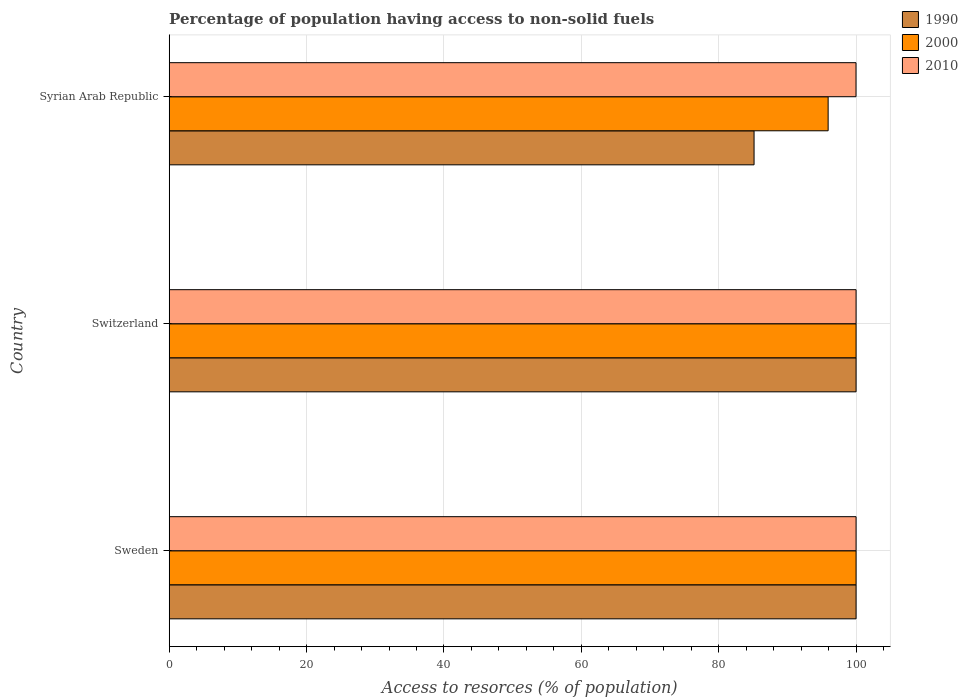How many different coloured bars are there?
Provide a succinct answer. 3. How many bars are there on the 2nd tick from the bottom?
Make the answer very short. 3. What is the label of the 2nd group of bars from the top?
Provide a short and direct response. Switzerland. In how many cases, is the number of bars for a given country not equal to the number of legend labels?
Your answer should be very brief. 0. What is the percentage of population having access to non-solid fuels in 1990 in Syrian Arab Republic?
Offer a terse response. 85.15. Across all countries, what is the minimum percentage of population having access to non-solid fuels in 1990?
Your answer should be very brief. 85.15. In which country was the percentage of population having access to non-solid fuels in 1990 minimum?
Offer a very short reply. Syrian Arab Republic. What is the total percentage of population having access to non-solid fuels in 1990 in the graph?
Your answer should be very brief. 285.15. What is the difference between the percentage of population having access to non-solid fuels in 2000 in Sweden and that in Switzerland?
Provide a short and direct response. 0. What is the average percentage of population having access to non-solid fuels in 1990 per country?
Offer a very short reply. 95.05. What is the difference between the percentage of population having access to non-solid fuels in 2010 and percentage of population having access to non-solid fuels in 2000 in Syrian Arab Republic?
Offer a very short reply. 4.06. In how many countries, is the percentage of population having access to non-solid fuels in 1990 greater than 60 %?
Offer a very short reply. 3. What is the ratio of the percentage of population having access to non-solid fuels in 2000 in Switzerland to that in Syrian Arab Republic?
Offer a very short reply. 1.04. What is the difference between the highest and the lowest percentage of population having access to non-solid fuels in 2010?
Make the answer very short. 0.01. Is the sum of the percentage of population having access to non-solid fuels in 1990 in Sweden and Switzerland greater than the maximum percentage of population having access to non-solid fuels in 2000 across all countries?
Ensure brevity in your answer.  Yes. Are all the bars in the graph horizontal?
Provide a short and direct response. Yes. How many countries are there in the graph?
Keep it short and to the point. 3. What is the difference between two consecutive major ticks on the X-axis?
Provide a succinct answer. 20. Are the values on the major ticks of X-axis written in scientific E-notation?
Give a very brief answer. No. Does the graph contain any zero values?
Your response must be concise. No. Does the graph contain grids?
Make the answer very short. Yes. Where does the legend appear in the graph?
Ensure brevity in your answer.  Top right. How many legend labels are there?
Ensure brevity in your answer.  3. What is the title of the graph?
Your answer should be very brief. Percentage of population having access to non-solid fuels. What is the label or title of the X-axis?
Give a very brief answer. Access to resorces (% of population). What is the label or title of the Y-axis?
Ensure brevity in your answer.  Country. What is the Access to resorces (% of population) of 1990 in Sweden?
Give a very brief answer. 100. What is the Access to resorces (% of population) of 2000 in Sweden?
Your response must be concise. 100. What is the Access to resorces (% of population) of 2010 in Sweden?
Make the answer very short. 100. What is the Access to resorces (% of population) of 1990 in Switzerland?
Offer a very short reply. 100. What is the Access to resorces (% of population) in 2000 in Switzerland?
Your response must be concise. 100. What is the Access to resorces (% of population) in 1990 in Syrian Arab Republic?
Offer a very short reply. 85.15. What is the Access to resorces (% of population) in 2000 in Syrian Arab Republic?
Keep it short and to the point. 95.93. What is the Access to resorces (% of population) of 2010 in Syrian Arab Republic?
Give a very brief answer. 99.99. Across all countries, what is the maximum Access to resorces (% of population) in 2000?
Offer a very short reply. 100. Across all countries, what is the maximum Access to resorces (% of population) in 2010?
Your response must be concise. 100. Across all countries, what is the minimum Access to resorces (% of population) of 1990?
Give a very brief answer. 85.15. Across all countries, what is the minimum Access to resorces (% of population) in 2000?
Your answer should be compact. 95.93. Across all countries, what is the minimum Access to resorces (% of population) in 2010?
Ensure brevity in your answer.  99.99. What is the total Access to resorces (% of population) of 1990 in the graph?
Your response must be concise. 285.15. What is the total Access to resorces (% of population) in 2000 in the graph?
Provide a succinct answer. 295.93. What is the total Access to resorces (% of population) of 2010 in the graph?
Ensure brevity in your answer.  299.99. What is the difference between the Access to resorces (% of population) in 1990 in Sweden and that in Switzerland?
Ensure brevity in your answer.  0. What is the difference between the Access to resorces (% of population) in 1990 in Sweden and that in Syrian Arab Republic?
Ensure brevity in your answer.  14.85. What is the difference between the Access to resorces (% of population) of 2000 in Sweden and that in Syrian Arab Republic?
Make the answer very short. 4.07. What is the difference between the Access to resorces (% of population) in 1990 in Switzerland and that in Syrian Arab Republic?
Offer a terse response. 14.85. What is the difference between the Access to resorces (% of population) of 2000 in Switzerland and that in Syrian Arab Republic?
Your answer should be very brief. 4.07. What is the difference between the Access to resorces (% of population) of 2010 in Switzerland and that in Syrian Arab Republic?
Provide a short and direct response. 0.01. What is the difference between the Access to resorces (% of population) in 1990 in Sweden and the Access to resorces (% of population) in 2000 in Switzerland?
Provide a succinct answer. 0. What is the difference between the Access to resorces (% of population) in 1990 in Sweden and the Access to resorces (% of population) in 2000 in Syrian Arab Republic?
Your answer should be very brief. 4.07. What is the difference between the Access to resorces (% of population) of 1990 in Sweden and the Access to resorces (% of population) of 2010 in Syrian Arab Republic?
Your answer should be compact. 0.01. What is the difference between the Access to resorces (% of population) in 1990 in Switzerland and the Access to resorces (% of population) in 2000 in Syrian Arab Republic?
Offer a very short reply. 4.07. What is the average Access to resorces (% of population) of 1990 per country?
Ensure brevity in your answer.  95.05. What is the average Access to resorces (% of population) of 2000 per country?
Give a very brief answer. 98.64. What is the average Access to resorces (% of population) of 2010 per country?
Ensure brevity in your answer.  100. What is the difference between the Access to resorces (% of population) of 1990 and Access to resorces (% of population) of 2000 in Sweden?
Your response must be concise. 0. What is the difference between the Access to resorces (% of population) of 1990 and Access to resorces (% of population) of 2010 in Sweden?
Make the answer very short. 0. What is the difference between the Access to resorces (% of population) of 1990 and Access to resorces (% of population) of 2000 in Switzerland?
Offer a terse response. 0. What is the difference between the Access to resorces (% of population) in 2000 and Access to resorces (% of population) in 2010 in Switzerland?
Offer a very short reply. 0. What is the difference between the Access to resorces (% of population) of 1990 and Access to resorces (% of population) of 2000 in Syrian Arab Republic?
Make the answer very short. -10.78. What is the difference between the Access to resorces (% of population) in 1990 and Access to resorces (% of population) in 2010 in Syrian Arab Republic?
Provide a succinct answer. -14.84. What is the difference between the Access to resorces (% of population) in 2000 and Access to resorces (% of population) in 2010 in Syrian Arab Republic?
Give a very brief answer. -4.06. What is the ratio of the Access to resorces (% of population) in 1990 in Sweden to that in Switzerland?
Make the answer very short. 1. What is the ratio of the Access to resorces (% of population) in 2000 in Sweden to that in Switzerland?
Offer a terse response. 1. What is the ratio of the Access to resorces (% of population) of 1990 in Sweden to that in Syrian Arab Republic?
Ensure brevity in your answer.  1.17. What is the ratio of the Access to resorces (% of population) of 2000 in Sweden to that in Syrian Arab Republic?
Offer a very short reply. 1.04. What is the ratio of the Access to resorces (% of population) in 2010 in Sweden to that in Syrian Arab Republic?
Provide a short and direct response. 1. What is the ratio of the Access to resorces (% of population) of 1990 in Switzerland to that in Syrian Arab Republic?
Provide a succinct answer. 1.17. What is the ratio of the Access to resorces (% of population) in 2000 in Switzerland to that in Syrian Arab Republic?
Provide a short and direct response. 1.04. What is the difference between the highest and the second highest Access to resorces (% of population) in 2010?
Your answer should be compact. 0. What is the difference between the highest and the lowest Access to resorces (% of population) of 1990?
Ensure brevity in your answer.  14.85. What is the difference between the highest and the lowest Access to resorces (% of population) of 2000?
Your response must be concise. 4.07. What is the difference between the highest and the lowest Access to resorces (% of population) in 2010?
Your response must be concise. 0.01. 